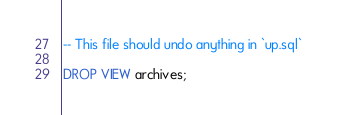<code> <loc_0><loc_0><loc_500><loc_500><_SQL_>-- This file should undo anything in `up.sql`

DROP VIEW archives;</code> 